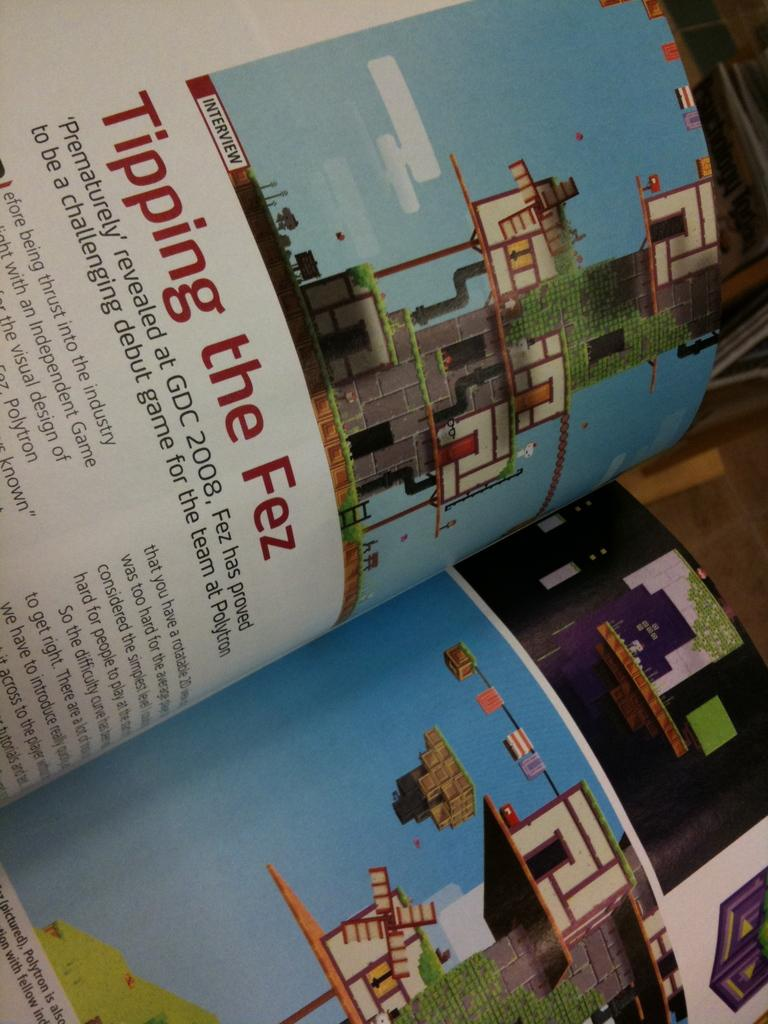Provide a one-sentence caption for the provided image. A book opened to a page regarding the game Fez. 